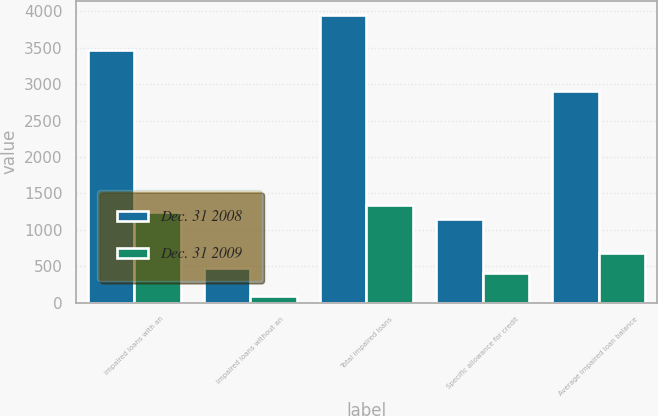Convert chart to OTSL. <chart><loc_0><loc_0><loc_500><loc_500><stacked_bar_chart><ecel><fcel>Impaired loans with an<fcel>Impaired loans without an<fcel>Total impaired loans<fcel>Specific allowance for credit<fcel>Average impaired loan balance<nl><fcel>Dec. 31 2008<fcel>3475<fcel>471<fcel>3946<fcel>1148<fcel>2909<nl><fcel>Dec. 31 2009<fcel>1249<fcel>93<fcel>1342<fcel>405<fcel>674<nl></chart> 